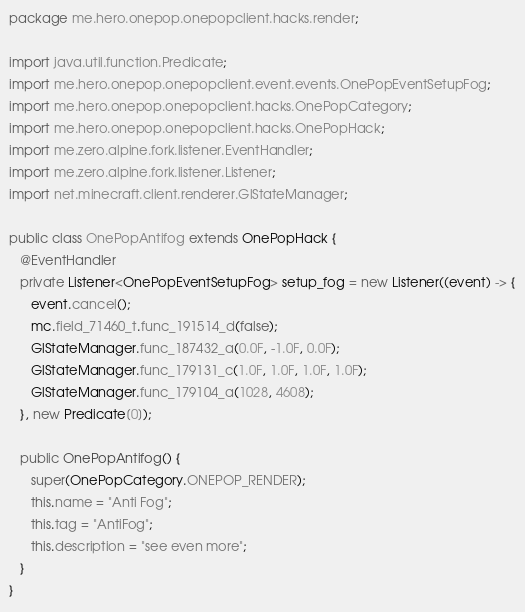<code> <loc_0><loc_0><loc_500><loc_500><_Java_>package me.hero.onepop.onepopclient.hacks.render;

import java.util.function.Predicate;
import me.hero.onepop.onepopclient.event.events.OnePopEventSetupFog;
import me.hero.onepop.onepopclient.hacks.OnePopCategory;
import me.hero.onepop.onepopclient.hacks.OnePopHack;
import me.zero.alpine.fork.listener.EventHandler;
import me.zero.alpine.fork.listener.Listener;
import net.minecraft.client.renderer.GlStateManager;

public class OnePopAntifog extends OnePopHack {
   @EventHandler
   private Listener<OnePopEventSetupFog> setup_fog = new Listener((event) -> {
      event.cancel();
      mc.field_71460_t.func_191514_d(false);
      GlStateManager.func_187432_a(0.0F, -1.0F, 0.0F);
      GlStateManager.func_179131_c(1.0F, 1.0F, 1.0F, 1.0F);
      GlStateManager.func_179104_a(1028, 4608);
   }, new Predicate[0]);

   public OnePopAntifog() {
      super(OnePopCategory.ONEPOP_RENDER);
      this.name = "Anti Fog";
      this.tag = "AntiFog";
      this.description = "see even more";
   }
}
</code> 